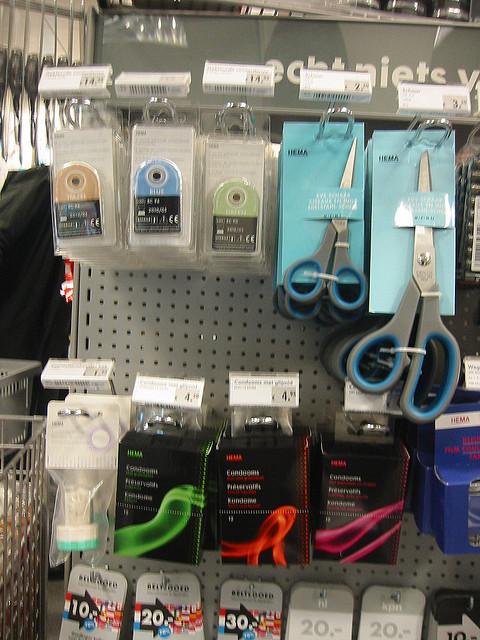What kind of shop is this?
Answer briefly. Craft. What color is the scissors on the top shelf?
Give a very brief answer. Gray. What does this store specialize in?
Give a very brief answer. Crafts. What is the name of device that the merchandise is hanging from?
Short answer required. Hook. 